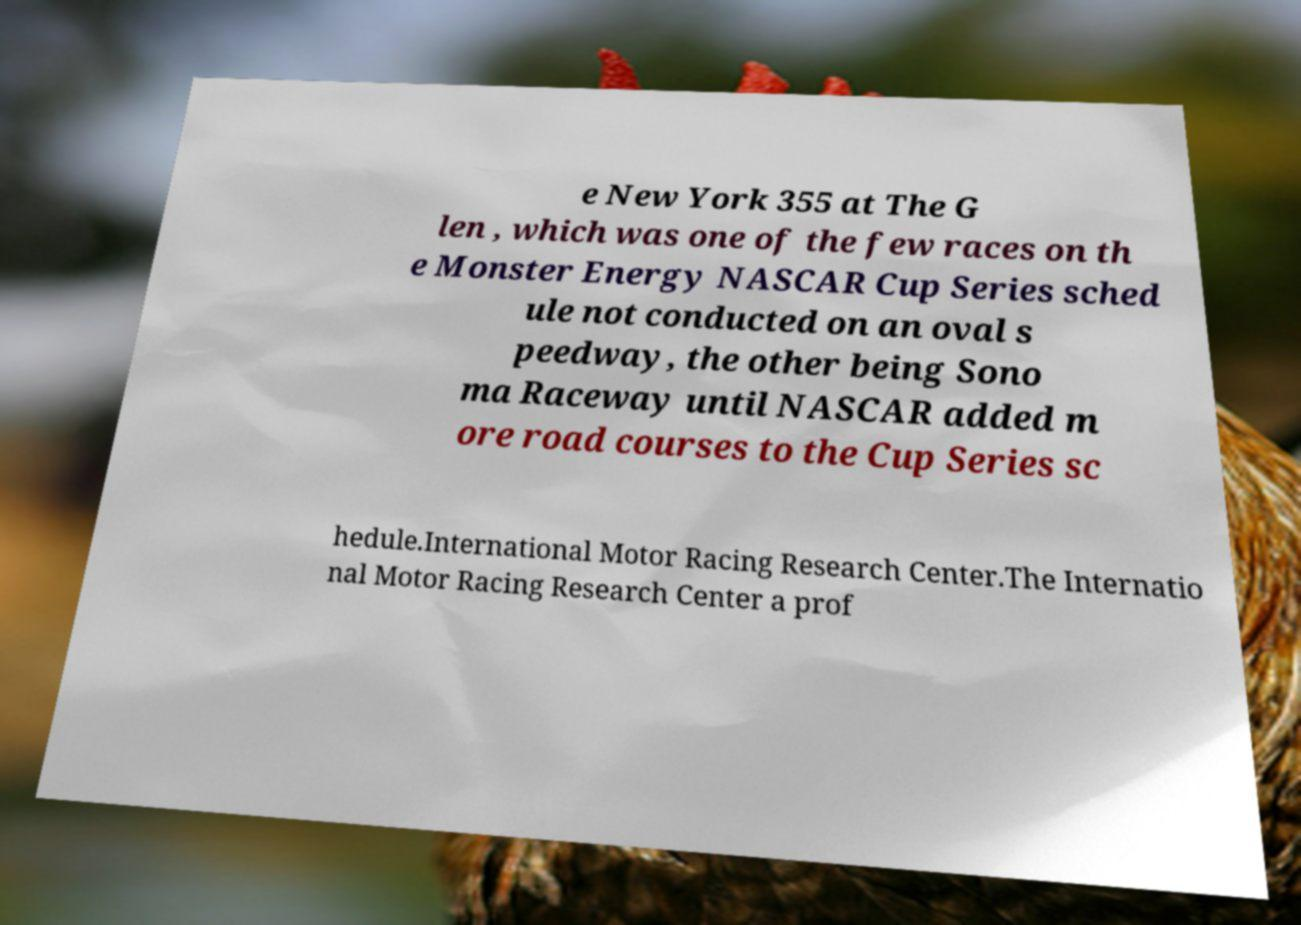Please identify and transcribe the text found in this image. e New York 355 at The G len , which was one of the few races on th e Monster Energy NASCAR Cup Series sched ule not conducted on an oval s peedway, the other being Sono ma Raceway until NASCAR added m ore road courses to the Cup Series sc hedule.International Motor Racing Research Center.The Internatio nal Motor Racing Research Center a prof 